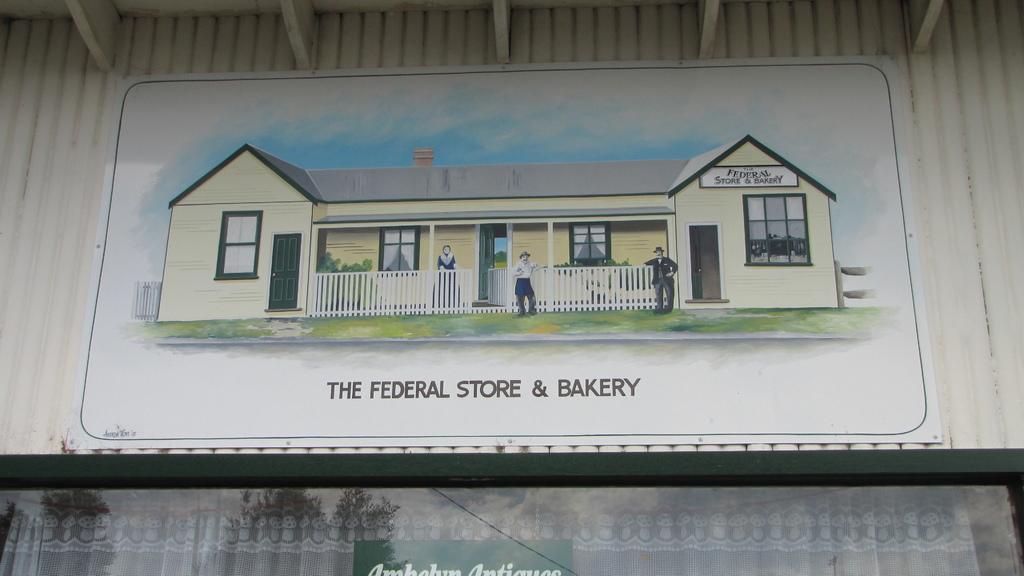How would you summarize this image in a sentence or two? This is a shed. In the center of the image we can see a poster. At the bottom of the image we can see cloth, board. In the background of the image we can see roof, wall. 